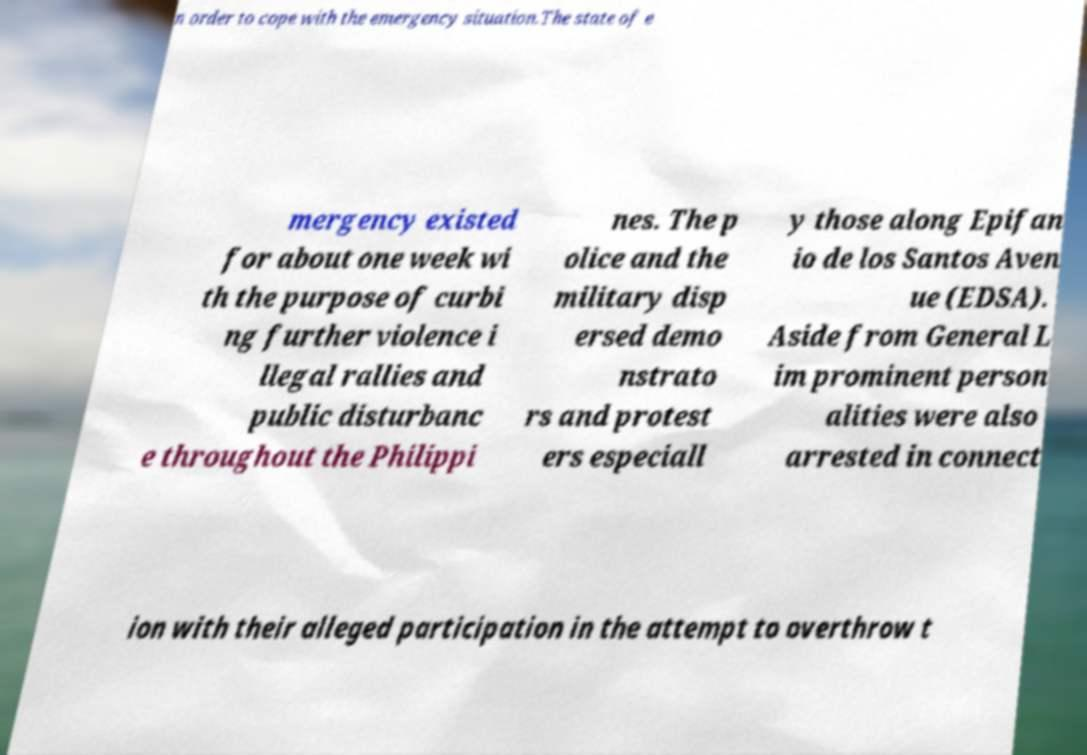Please read and relay the text visible in this image. What does it say? n order to cope with the emergency situation.The state of e mergency existed for about one week wi th the purpose of curbi ng further violence i llegal rallies and public disturbanc e throughout the Philippi nes. The p olice and the military disp ersed demo nstrato rs and protest ers especiall y those along Epifan io de los Santos Aven ue (EDSA). Aside from General L im prominent person alities were also arrested in connect ion with their alleged participation in the attempt to overthrow t 